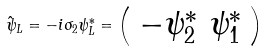Convert formula to latex. <formula><loc_0><loc_0><loc_500><loc_500>\hat { \psi } _ { L } = - i \sigma _ { 2 } \psi _ { L } ^ { \ast } = \left ( \begin{array} { c } { { - \psi _ { 2 } ^ { \ast } \ \psi _ { 1 } ^ { \ast } } } \end{array} \right )</formula> 